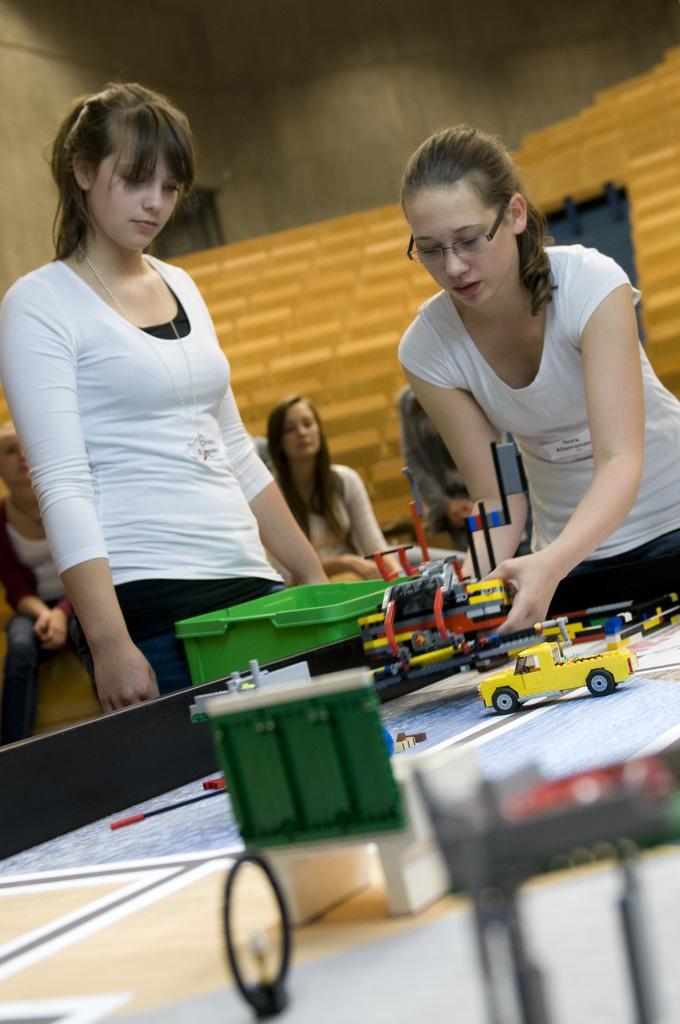In one or two sentences, can you explain what this image depicts? This is the picture taken in a room, there are group of people in this room in front of the people there is a table on the table there is a paper, toys and box. Background of the people is a wall. 